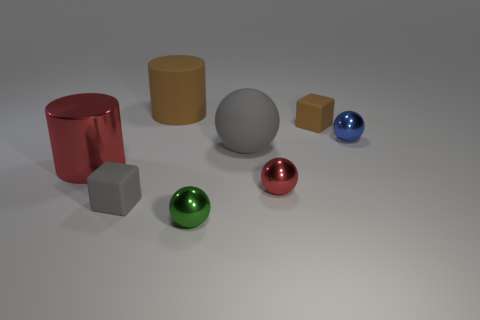Are there fewer cylinders on the left side of the shiny cylinder than big gray things that are in front of the small blue ball?
Make the answer very short. Yes. Are there any big rubber objects to the right of the blue metal thing?
Your answer should be very brief. No. There is a small block that is to the left of the tiny object that is behind the blue shiny object; are there any brown objects to the left of it?
Make the answer very short. No. Is the shape of the gray object that is to the right of the green metallic thing the same as  the tiny brown object?
Offer a terse response. No. There is a cylinder that is made of the same material as the red ball; what is its color?
Ensure brevity in your answer.  Red. What number of big brown cylinders have the same material as the brown block?
Give a very brief answer. 1. There is a block to the left of the green object on the right side of the cylinder behind the red shiny cylinder; what color is it?
Your answer should be compact. Gray. Do the gray block and the green shiny ball have the same size?
Offer a terse response. Yes. Is there anything else that has the same shape as the big gray object?
Keep it short and to the point. Yes. What number of objects are red objects on the left side of the gray cube or large blue metal cylinders?
Offer a very short reply. 1. 